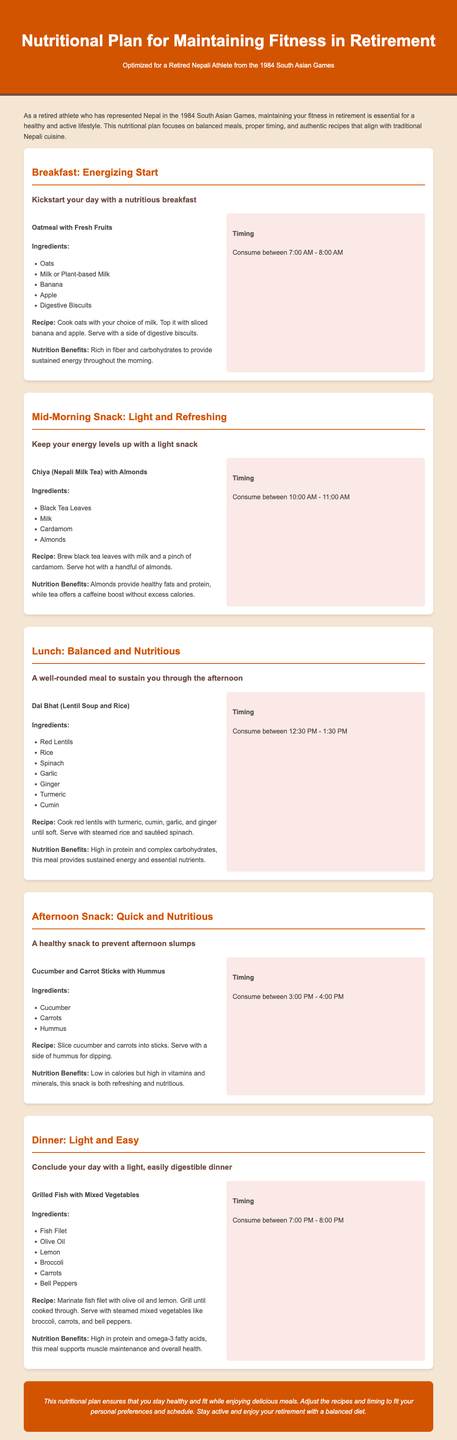What is the title of the document? The title of the document is provided in the header section and summarizes the focus of the content.
Answer: Nutritional Plan for Maintaining Fitness in Retirement What is the first meal suggested in the plan? The first meal is found in the breakfast section of the document, detailing the name of the dish.
Answer: Oatmeal with Fresh Fruits What are the ingredients for the Mid-Morning Snack? The ingredients can be found listed under the respective meal section for the Mid-Morning Snack in the document.
Answer: Black Tea Leaves, Milk, Cardamom, Almonds What time should lunch be consumed? The recommended lunch timing is specified in the timing section accompanying the lunch meal information.
Answer: 12:30 PM - 1:30 PM What is the nutrition benefit of the grilled fish meal? The nutrition benefits are detailed after the recipe, summarizing the advantages of the meal.
Answer: High in protein and omega-3 fatty acids What type of tea is mentioned for the Mid-Morning Snack? The type of tea is included in the meal description for the Mid-Morning Snack section of the document.
Answer: Chiya (Nepali Milk Tea) Which meal includes carrots as an ingredient? The inclusion of carrots is noted in the meal sections of the document, specifically identifying where they appear.
Answer: Afternoon Snack How many meals are outlined in the nutritional plan? The total count of meals can be inferred from the distinct sections provided within the document.
Answer: Five meals What is the primary focus of the nutritional plan? The overall aim of the document is indicated in the introduction, summarizing the purpose of the nutritional strategy.
Answer: Maintaining fitness in retirement 